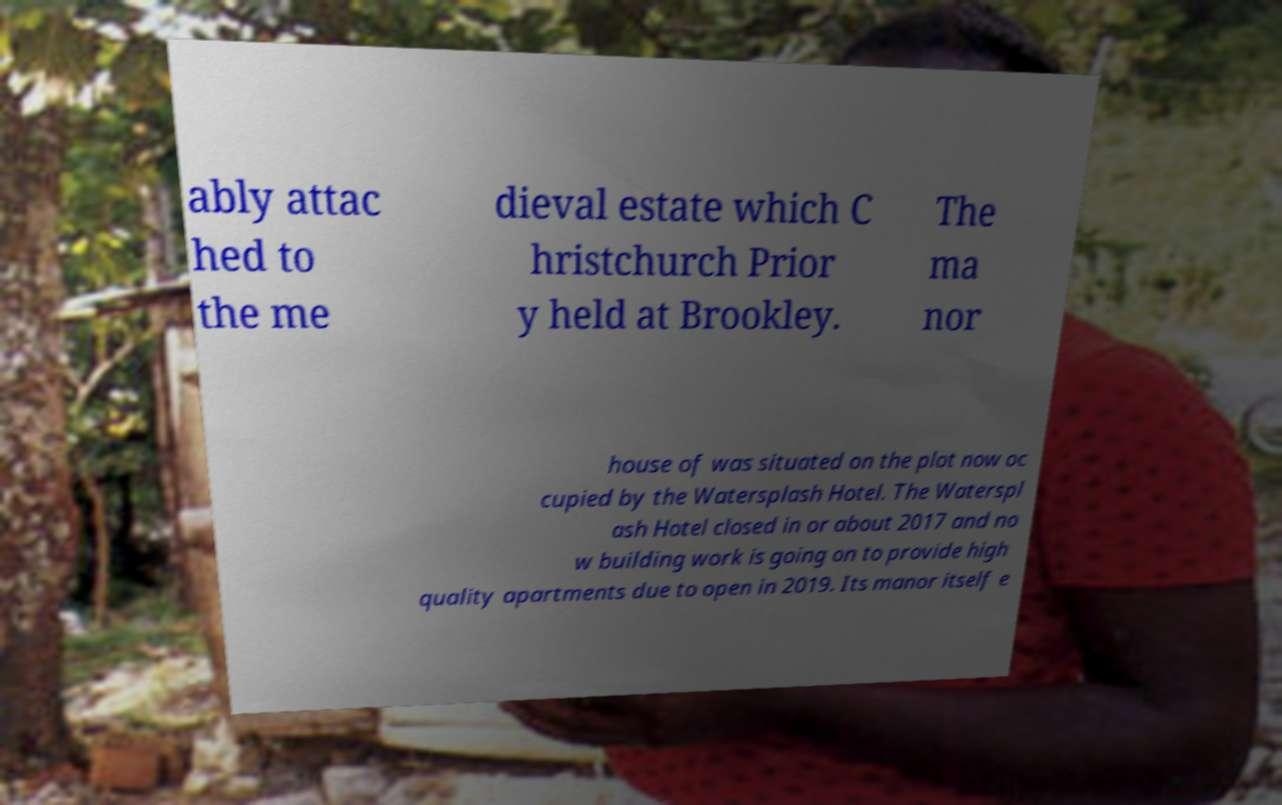Can you read and provide the text displayed in the image?This photo seems to have some interesting text. Can you extract and type it out for me? ably attac hed to the me dieval estate which C hristchurch Prior y held at Brookley. The ma nor house of was situated on the plot now oc cupied by the Watersplash Hotel. The Waterspl ash Hotel closed in or about 2017 and no w building work is going on to provide high quality apartments due to open in 2019. Its manor itself e 